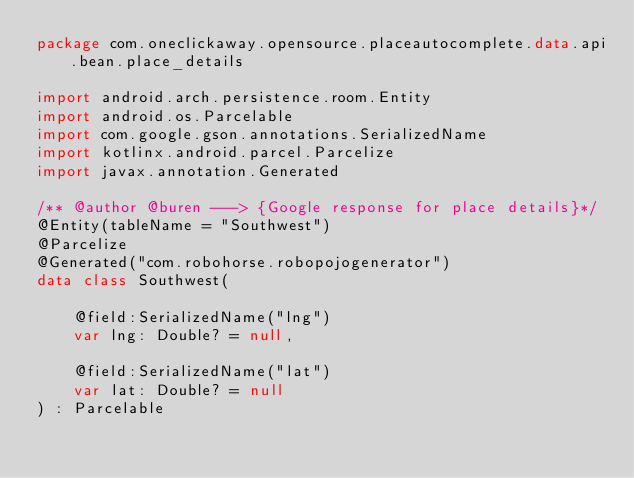Convert code to text. <code><loc_0><loc_0><loc_500><loc_500><_Kotlin_>package com.oneclickaway.opensource.placeautocomplete.data.api.bean.place_details

import android.arch.persistence.room.Entity
import android.os.Parcelable
import com.google.gson.annotations.SerializedName
import kotlinx.android.parcel.Parcelize
import javax.annotation.Generated

/** @author @buren ---> {Google response for place details}*/
@Entity(tableName = "Southwest")
@Parcelize
@Generated("com.robohorse.robopojogenerator")
data class Southwest(

    @field:SerializedName("lng")
    var lng: Double? = null,

    @field:SerializedName("lat")
    var lat: Double? = null
) : Parcelable</code> 